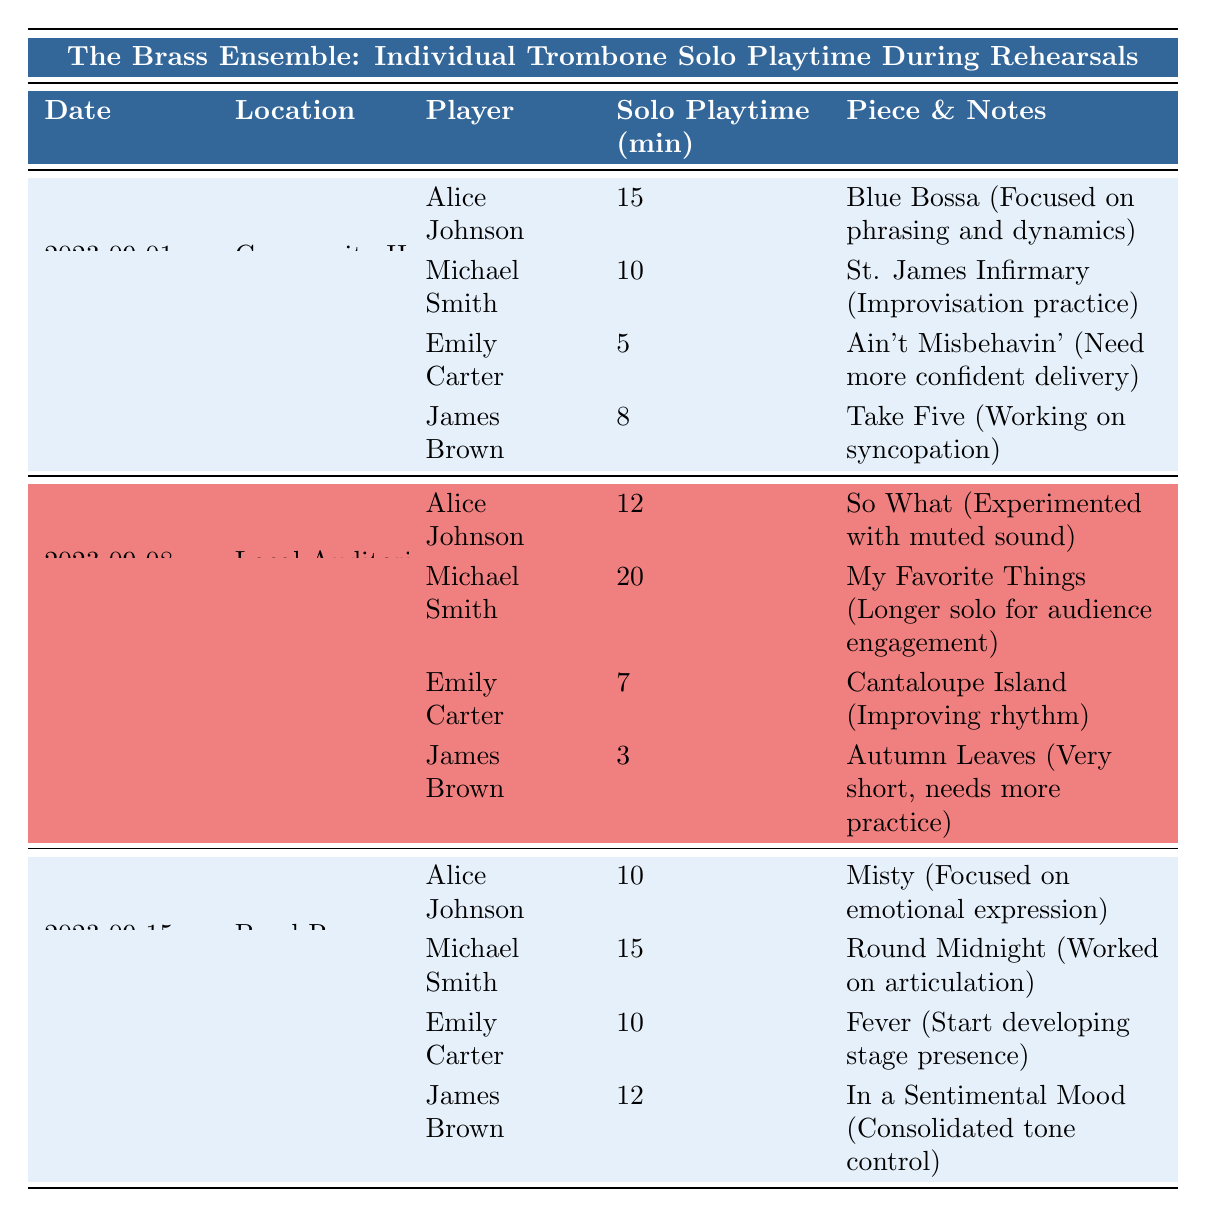What player had the longest solo playtime on September 8, 2023? On September 8, 2023, Michael Smith had the longest solo playtime of 20 minutes. This can be seen in the second row of the table for that date.
Answer: Michael Smith What was the total solo playtime for Alice Johnson across all rehearsals? Alice Johnson played for 15 minutes on September 1, 12 minutes on September 8, and 10 minutes on September 15. Adding these gives 15 + 12 + 10 = 37 minutes total.
Answer: 37 minutes Did Emily Carter ever have more solo playtime than James Brown? Yes, on September 1 and September 15, Emily Carter had more playtime than James Brown (5 vs 8 on September 1, and 10 vs 12 on September 15).
Answer: Yes What is the average solo playtime for all players on September 1, 2023? On September 1, the total solo playtime was 15 (Alice) + 10 (Michael) + 5 (Emily) + 8 (James) = 38 minutes. There are 4 players, so the average is 38/4 = 9.5 minutes.
Answer: 9.5 minutes What piece did Michael Smith play the most often? Michael Smith played "St. James Infirmary" on September 1 and "My Favorite Things" on September 8, but he did not play any piece more than once, so there is no piece played more often.
Answer: None Which piece had the shortest solo playtime and who played it? On September 8, 2023, James Brown played "Autumn Leaves" for only 3 minutes, which is the shortest solo playtime recorded in the table.
Answer: Autumn Leaves by James Brown 